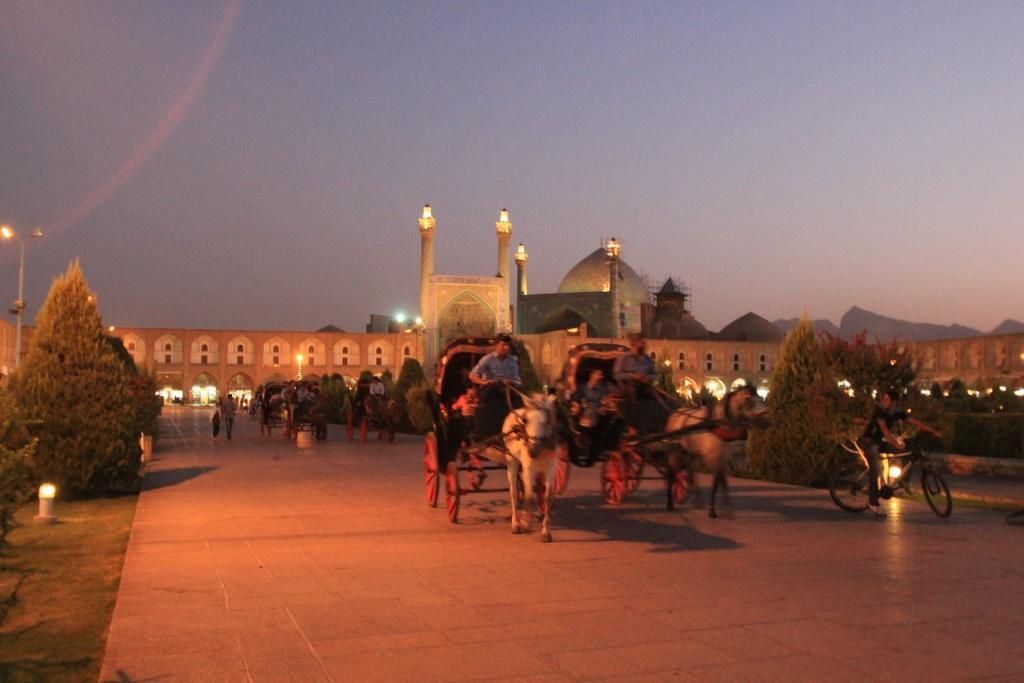Please provide a concise description of this image. In this image I can see a path in the centre and on it I can see few horse carts and people. I can also see few people are sitting on these carts and on the right side I can see one person is sitting on a bicycle. On the both side of the path I can see number of trees. In the background I can see a building, number of lights and the sky. On the left side of this image I can see a pole, few lights and I can also see few more lights in the front. 